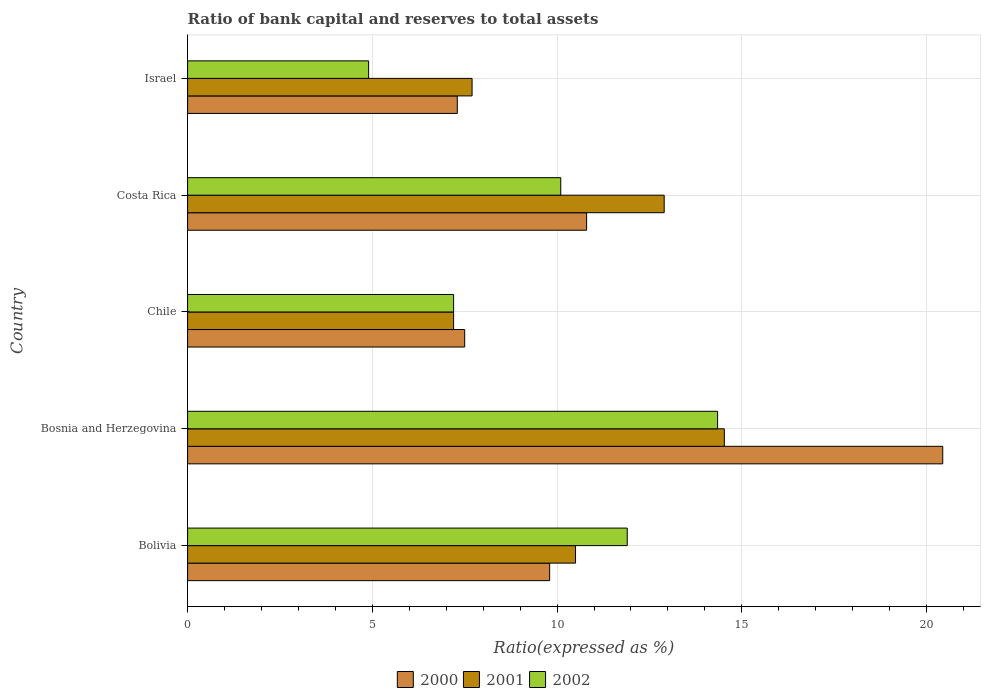How many different coloured bars are there?
Your answer should be very brief. 3. Are the number of bars per tick equal to the number of legend labels?
Provide a short and direct response. Yes. Are the number of bars on each tick of the Y-axis equal?
Provide a succinct answer. Yes. How many bars are there on the 1st tick from the bottom?
Offer a very short reply. 3. In how many cases, is the number of bars for a given country not equal to the number of legend labels?
Give a very brief answer. 0. What is the ratio of bank capital and reserves to total assets in 2002 in Israel?
Make the answer very short. 4.9. Across all countries, what is the maximum ratio of bank capital and reserves to total assets in 2001?
Your answer should be compact. 14.53. Across all countries, what is the minimum ratio of bank capital and reserves to total assets in 2001?
Give a very brief answer. 7.2. In which country was the ratio of bank capital and reserves to total assets in 2000 maximum?
Offer a terse response. Bosnia and Herzegovina. In which country was the ratio of bank capital and reserves to total assets in 2001 minimum?
Provide a succinct answer. Chile. What is the total ratio of bank capital and reserves to total assets in 2002 in the graph?
Offer a very short reply. 48.45. What is the difference between the ratio of bank capital and reserves to total assets in 2002 in Bolivia and that in Costa Rica?
Make the answer very short. 1.8. What is the difference between the ratio of bank capital and reserves to total assets in 2000 in Bosnia and Herzegovina and the ratio of bank capital and reserves to total assets in 2002 in Costa Rica?
Give a very brief answer. 10.34. What is the average ratio of bank capital and reserves to total assets in 2002 per country?
Offer a terse response. 9.69. What is the difference between the ratio of bank capital and reserves to total assets in 2002 and ratio of bank capital and reserves to total assets in 2001 in Costa Rica?
Offer a very short reply. -2.8. In how many countries, is the ratio of bank capital and reserves to total assets in 2001 greater than 1 %?
Provide a succinct answer. 5. What is the ratio of the ratio of bank capital and reserves to total assets in 2000 in Bosnia and Herzegovina to that in Chile?
Make the answer very short. 2.73. What is the difference between the highest and the second highest ratio of bank capital and reserves to total assets in 2000?
Provide a short and direct response. 9.64. What is the difference between the highest and the lowest ratio of bank capital and reserves to total assets in 2000?
Your response must be concise. 13.14. In how many countries, is the ratio of bank capital and reserves to total assets in 2000 greater than the average ratio of bank capital and reserves to total assets in 2000 taken over all countries?
Provide a short and direct response. 1. Is the sum of the ratio of bank capital and reserves to total assets in 2000 in Chile and Israel greater than the maximum ratio of bank capital and reserves to total assets in 2002 across all countries?
Offer a very short reply. Yes. What does the 3rd bar from the top in Costa Rica represents?
Ensure brevity in your answer.  2000. What does the 2nd bar from the bottom in Costa Rica represents?
Your response must be concise. 2001. How many bars are there?
Ensure brevity in your answer.  15. How many countries are there in the graph?
Provide a succinct answer. 5. Are the values on the major ticks of X-axis written in scientific E-notation?
Your answer should be very brief. No. How many legend labels are there?
Provide a succinct answer. 3. How are the legend labels stacked?
Your answer should be very brief. Horizontal. What is the title of the graph?
Offer a very short reply. Ratio of bank capital and reserves to total assets. What is the label or title of the X-axis?
Provide a short and direct response. Ratio(expressed as %). What is the label or title of the Y-axis?
Keep it short and to the point. Country. What is the Ratio(expressed as %) of 2002 in Bolivia?
Ensure brevity in your answer.  11.9. What is the Ratio(expressed as %) in 2000 in Bosnia and Herzegovina?
Your answer should be compact. 20.44. What is the Ratio(expressed as %) of 2001 in Bosnia and Herzegovina?
Your answer should be very brief. 14.53. What is the Ratio(expressed as %) in 2002 in Bosnia and Herzegovina?
Offer a very short reply. 14.35. What is the Ratio(expressed as %) in 2000 in Chile?
Provide a short and direct response. 7.5. What is the Ratio(expressed as %) of 2002 in Chile?
Your answer should be very brief. 7.2. What is the Ratio(expressed as %) of 2000 in Costa Rica?
Ensure brevity in your answer.  10.8. What is the Ratio(expressed as %) in 2001 in Costa Rica?
Your response must be concise. 12.9. What is the Ratio(expressed as %) of 2001 in Israel?
Provide a short and direct response. 7.7. Across all countries, what is the maximum Ratio(expressed as %) in 2000?
Your answer should be compact. 20.44. Across all countries, what is the maximum Ratio(expressed as %) of 2001?
Offer a terse response. 14.53. Across all countries, what is the maximum Ratio(expressed as %) of 2002?
Make the answer very short. 14.35. Across all countries, what is the minimum Ratio(expressed as %) in 2000?
Provide a succinct answer. 7.3. Across all countries, what is the minimum Ratio(expressed as %) in 2001?
Your response must be concise. 7.2. Across all countries, what is the minimum Ratio(expressed as %) in 2002?
Make the answer very short. 4.9. What is the total Ratio(expressed as %) of 2000 in the graph?
Your answer should be compact. 55.84. What is the total Ratio(expressed as %) of 2001 in the graph?
Provide a succinct answer. 52.83. What is the total Ratio(expressed as %) of 2002 in the graph?
Offer a terse response. 48.45. What is the difference between the Ratio(expressed as %) in 2000 in Bolivia and that in Bosnia and Herzegovina?
Your answer should be very brief. -10.64. What is the difference between the Ratio(expressed as %) of 2001 in Bolivia and that in Bosnia and Herzegovina?
Offer a terse response. -4.03. What is the difference between the Ratio(expressed as %) in 2002 in Bolivia and that in Bosnia and Herzegovina?
Make the answer very short. -2.45. What is the difference between the Ratio(expressed as %) of 2000 in Bolivia and that in Chile?
Give a very brief answer. 2.3. What is the difference between the Ratio(expressed as %) of 2002 in Bolivia and that in Chile?
Your answer should be very brief. 4.7. What is the difference between the Ratio(expressed as %) of 2001 in Bolivia and that in Israel?
Keep it short and to the point. 2.8. What is the difference between the Ratio(expressed as %) of 2002 in Bolivia and that in Israel?
Your response must be concise. 7. What is the difference between the Ratio(expressed as %) in 2000 in Bosnia and Herzegovina and that in Chile?
Ensure brevity in your answer.  12.94. What is the difference between the Ratio(expressed as %) of 2001 in Bosnia and Herzegovina and that in Chile?
Provide a succinct answer. 7.33. What is the difference between the Ratio(expressed as %) in 2002 in Bosnia and Herzegovina and that in Chile?
Your answer should be very brief. 7.15. What is the difference between the Ratio(expressed as %) in 2000 in Bosnia and Herzegovina and that in Costa Rica?
Keep it short and to the point. 9.64. What is the difference between the Ratio(expressed as %) of 2001 in Bosnia and Herzegovina and that in Costa Rica?
Ensure brevity in your answer.  1.63. What is the difference between the Ratio(expressed as %) of 2002 in Bosnia and Herzegovina and that in Costa Rica?
Give a very brief answer. 4.25. What is the difference between the Ratio(expressed as %) in 2000 in Bosnia and Herzegovina and that in Israel?
Your answer should be very brief. 13.14. What is the difference between the Ratio(expressed as %) in 2001 in Bosnia and Herzegovina and that in Israel?
Your answer should be very brief. 6.83. What is the difference between the Ratio(expressed as %) of 2002 in Bosnia and Herzegovina and that in Israel?
Provide a short and direct response. 9.45. What is the difference between the Ratio(expressed as %) in 2001 in Chile and that in Costa Rica?
Ensure brevity in your answer.  -5.7. What is the difference between the Ratio(expressed as %) of 2001 in Chile and that in Israel?
Ensure brevity in your answer.  -0.5. What is the difference between the Ratio(expressed as %) of 2002 in Chile and that in Israel?
Ensure brevity in your answer.  2.3. What is the difference between the Ratio(expressed as %) in 2000 in Costa Rica and that in Israel?
Make the answer very short. 3.5. What is the difference between the Ratio(expressed as %) of 2002 in Costa Rica and that in Israel?
Offer a terse response. 5.2. What is the difference between the Ratio(expressed as %) in 2000 in Bolivia and the Ratio(expressed as %) in 2001 in Bosnia and Herzegovina?
Give a very brief answer. -4.73. What is the difference between the Ratio(expressed as %) in 2000 in Bolivia and the Ratio(expressed as %) in 2002 in Bosnia and Herzegovina?
Provide a succinct answer. -4.55. What is the difference between the Ratio(expressed as %) of 2001 in Bolivia and the Ratio(expressed as %) of 2002 in Bosnia and Herzegovina?
Make the answer very short. -3.85. What is the difference between the Ratio(expressed as %) of 2000 in Bolivia and the Ratio(expressed as %) of 2001 in Chile?
Keep it short and to the point. 2.6. What is the difference between the Ratio(expressed as %) in 2000 in Bolivia and the Ratio(expressed as %) in 2001 in Costa Rica?
Your answer should be compact. -3.1. What is the difference between the Ratio(expressed as %) in 2000 in Bolivia and the Ratio(expressed as %) in 2002 in Costa Rica?
Keep it short and to the point. -0.3. What is the difference between the Ratio(expressed as %) of 2000 in Bosnia and Herzegovina and the Ratio(expressed as %) of 2001 in Chile?
Make the answer very short. 13.24. What is the difference between the Ratio(expressed as %) of 2000 in Bosnia and Herzegovina and the Ratio(expressed as %) of 2002 in Chile?
Offer a terse response. 13.24. What is the difference between the Ratio(expressed as %) of 2001 in Bosnia and Herzegovina and the Ratio(expressed as %) of 2002 in Chile?
Your answer should be very brief. 7.33. What is the difference between the Ratio(expressed as %) of 2000 in Bosnia and Herzegovina and the Ratio(expressed as %) of 2001 in Costa Rica?
Provide a succinct answer. 7.54. What is the difference between the Ratio(expressed as %) of 2000 in Bosnia and Herzegovina and the Ratio(expressed as %) of 2002 in Costa Rica?
Provide a succinct answer. 10.34. What is the difference between the Ratio(expressed as %) of 2001 in Bosnia and Herzegovina and the Ratio(expressed as %) of 2002 in Costa Rica?
Provide a short and direct response. 4.43. What is the difference between the Ratio(expressed as %) of 2000 in Bosnia and Herzegovina and the Ratio(expressed as %) of 2001 in Israel?
Make the answer very short. 12.74. What is the difference between the Ratio(expressed as %) of 2000 in Bosnia and Herzegovina and the Ratio(expressed as %) of 2002 in Israel?
Your answer should be compact. 15.54. What is the difference between the Ratio(expressed as %) of 2001 in Bosnia and Herzegovina and the Ratio(expressed as %) of 2002 in Israel?
Your answer should be very brief. 9.63. What is the difference between the Ratio(expressed as %) of 2000 in Chile and the Ratio(expressed as %) of 2001 in Costa Rica?
Provide a short and direct response. -5.4. What is the difference between the Ratio(expressed as %) in 2000 in Chile and the Ratio(expressed as %) in 2002 in Costa Rica?
Your answer should be compact. -2.6. What is the difference between the Ratio(expressed as %) of 2001 in Chile and the Ratio(expressed as %) of 2002 in Costa Rica?
Make the answer very short. -2.9. What is the difference between the Ratio(expressed as %) in 2001 in Chile and the Ratio(expressed as %) in 2002 in Israel?
Provide a short and direct response. 2.3. What is the average Ratio(expressed as %) of 2000 per country?
Provide a short and direct response. 11.17. What is the average Ratio(expressed as %) of 2001 per country?
Your response must be concise. 10.57. What is the average Ratio(expressed as %) of 2002 per country?
Make the answer very short. 9.69. What is the difference between the Ratio(expressed as %) of 2000 and Ratio(expressed as %) of 2002 in Bolivia?
Give a very brief answer. -2.1. What is the difference between the Ratio(expressed as %) of 2001 and Ratio(expressed as %) of 2002 in Bolivia?
Offer a very short reply. -1.4. What is the difference between the Ratio(expressed as %) of 2000 and Ratio(expressed as %) of 2001 in Bosnia and Herzegovina?
Make the answer very short. 5.91. What is the difference between the Ratio(expressed as %) in 2000 and Ratio(expressed as %) in 2002 in Bosnia and Herzegovina?
Your answer should be compact. 6.09. What is the difference between the Ratio(expressed as %) of 2001 and Ratio(expressed as %) of 2002 in Bosnia and Herzegovina?
Your answer should be compact. 0.18. What is the difference between the Ratio(expressed as %) in 2000 and Ratio(expressed as %) in 2002 in Chile?
Offer a very short reply. 0.3. What is the difference between the Ratio(expressed as %) of 2000 and Ratio(expressed as %) of 2001 in Costa Rica?
Provide a succinct answer. -2.1. What is the difference between the Ratio(expressed as %) of 2001 and Ratio(expressed as %) of 2002 in Costa Rica?
Your answer should be very brief. 2.8. What is the difference between the Ratio(expressed as %) of 2000 and Ratio(expressed as %) of 2002 in Israel?
Offer a terse response. 2.4. What is the difference between the Ratio(expressed as %) in 2001 and Ratio(expressed as %) in 2002 in Israel?
Your response must be concise. 2.8. What is the ratio of the Ratio(expressed as %) in 2000 in Bolivia to that in Bosnia and Herzegovina?
Give a very brief answer. 0.48. What is the ratio of the Ratio(expressed as %) of 2001 in Bolivia to that in Bosnia and Herzegovina?
Offer a very short reply. 0.72. What is the ratio of the Ratio(expressed as %) of 2002 in Bolivia to that in Bosnia and Herzegovina?
Give a very brief answer. 0.83. What is the ratio of the Ratio(expressed as %) in 2000 in Bolivia to that in Chile?
Ensure brevity in your answer.  1.31. What is the ratio of the Ratio(expressed as %) of 2001 in Bolivia to that in Chile?
Give a very brief answer. 1.46. What is the ratio of the Ratio(expressed as %) of 2002 in Bolivia to that in Chile?
Provide a short and direct response. 1.65. What is the ratio of the Ratio(expressed as %) of 2000 in Bolivia to that in Costa Rica?
Ensure brevity in your answer.  0.91. What is the ratio of the Ratio(expressed as %) in 2001 in Bolivia to that in Costa Rica?
Provide a short and direct response. 0.81. What is the ratio of the Ratio(expressed as %) of 2002 in Bolivia to that in Costa Rica?
Ensure brevity in your answer.  1.18. What is the ratio of the Ratio(expressed as %) in 2000 in Bolivia to that in Israel?
Ensure brevity in your answer.  1.34. What is the ratio of the Ratio(expressed as %) of 2001 in Bolivia to that in Israel?
Provide a succinct answer. 1.36. What is the ratio of the Ratio(expressed as %) of 2002 in Bolivia to that in Israel?
Your response must be concise. 2.43. What is the ratio of the Ratio(expressed as %) of 2000 in Bosnia and Herzegovina to that in Chile?
Give a very brief answer. 2.73. What is the ratio of the Ratio(expressed as %) in 2001 in Bosnia and Herzegovina to that in Chile?
Your response must be concise. 2.02. What is the ratio of the Ratio(expressed as %) in 2002 in Bosnia and Herzegovina to that in Chile?
Provide a succinct answer. 1.99. What is the ratio of the Ratio(expressed as %) of 2000 in Bosnia and Herzegovina to that in Costa Rica?
Provide a succinct answer. 1.89. What is the ratio of the Ratio(expressed as %) of 2001 in Bosnia and Herzegovina to that in Costa Rica?
Your answer should be compact. 1.13. What is the ratio of the Ratio(expressed as %) in 2002 in Bosnia and Herzegovina to that in Costa Rica?
Offer a very short reply. 1.42. What is the ratio of the Ratio(expressed as %) in 2000 in Bosnia and Herzegovina to that in Israel?
Provide a succinct answer. 2.8. What is the ratio of the Ratio(expressed as %) in 2001 in Bosnia and Herzegovina to that in Israel?
Keep it short and to the point. 1.89. What is the ratio of the Ratio(expressed as %) of 2002 in Bosnia and Herzegovina to that in Israel?
Offer a terse response. 2.93. What is the ratio of the Ratio(expressed as %) in 2000 in Chile to that in Costa Rica?
Give a very brief answer. 0.69. What is the ratio of the Ratio(expressed as %) of 2001 in Chile to that in Costa Rica?
Give a very brief answer. 0.56. What is the ratio of the Ratio(expressed as %) in 2002 in Chile to that in Costa Rica?
Your answer should be compact. 0.71. What is the ratio of the Ratio(expressed as %) of 2000 in Chile to that in Israel?
Make the answer very short. 1.03. What is the ratio of the Ratio(expressed as %) in 2001 in Chile to that in Israel?
Offer a very short reply. 0.94. What is the ratio of the Ratio(expressed as %) of 2002 in Chile to that in Israel?
Make the answer very short. 1.47. What is the ratio of the Ratio(expressed as %) of 2000 in Costa Rica to that in Israel?
Your response must be concise. 1.48. What is the ratio of the Ratio(expressed as %) of 2001 in Costa Rica to that in Israel?
Your answer should be compact. 1.68. What is the ratio of the Ratio(expressed as %) of 2002 in Costa Rica to that in Israel?
Offer a very short reply. 2.06. What is the difference between the highest and the second highest Ratio(expressed as %) of 2000?
Provide a succinct answer. 9.64. What is the difference between the highest and the second highest Ratio(expressed as %) of 2001?
Give a very brief answer. 1.63. What is the difference between the highest and the second highest Ratio(expressed as %) of 2002?
Ensure brevity in your answer.  2.45. What is the difference between the highest and the lowest Ratio(expressed as %) of 2000?
Give a very brief answer. 13.14. What is the difference between the highest and the lowest Ratio(expressed as %) in 2001?
Offer a very short reply. 7.33. What is the difference between the highest and the lowest Ratio(expressed as %) of 2002?
Provide a short and direct response. 9.45. 